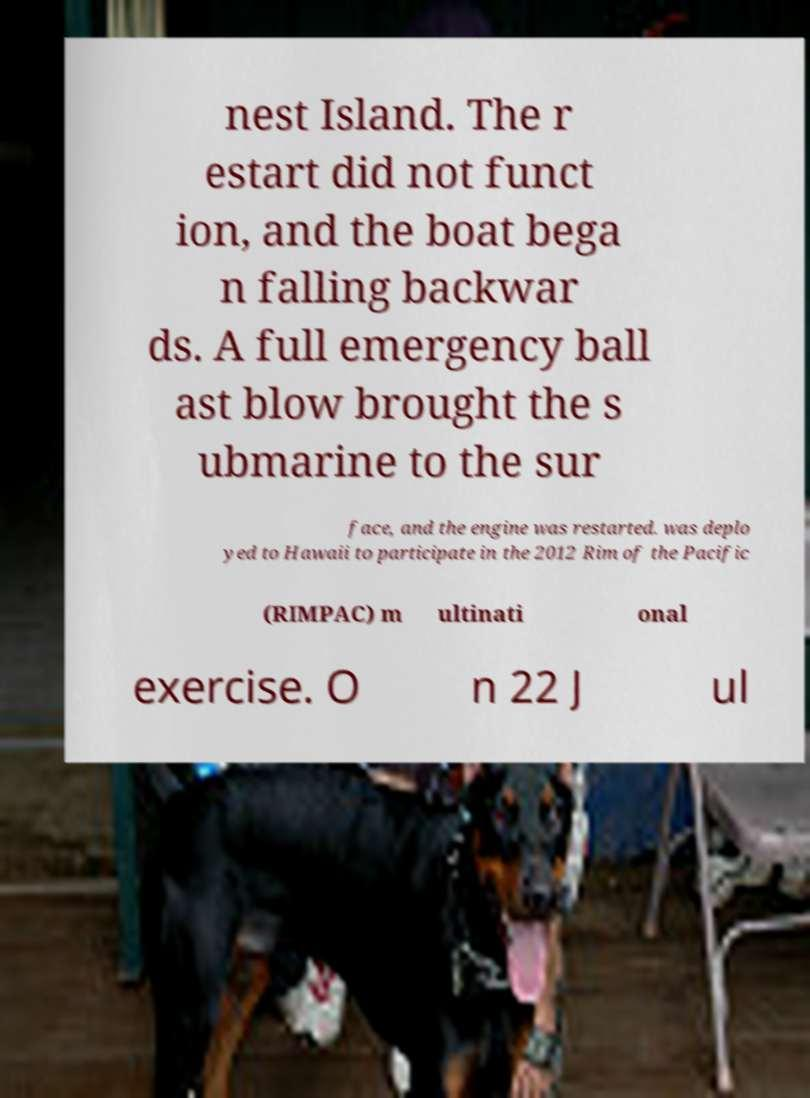There's text embedded in this image that I need extracted. Can you transcribe it verbatim? nest Island. The r estart did not funct ion, and the boat bega n falling backwar ds. A full emergency ball ast blow brought the s ubmarine to the sur face, and the engine was restarted. was deplo yed to Hawaii to participate in the 2012 Rim of the Pacific (RIMPAC) m ultinati onal exercise. O n 22 J ul 